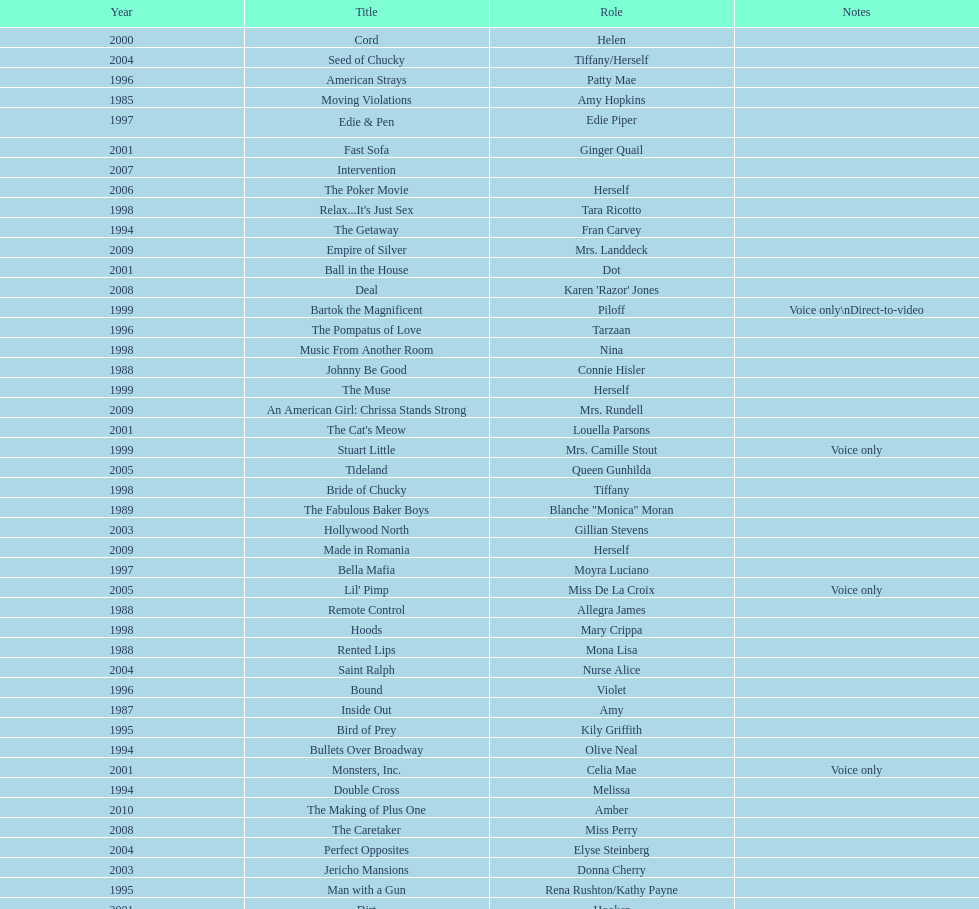How many films does jennifer tilly do a voice over role in? 5. 